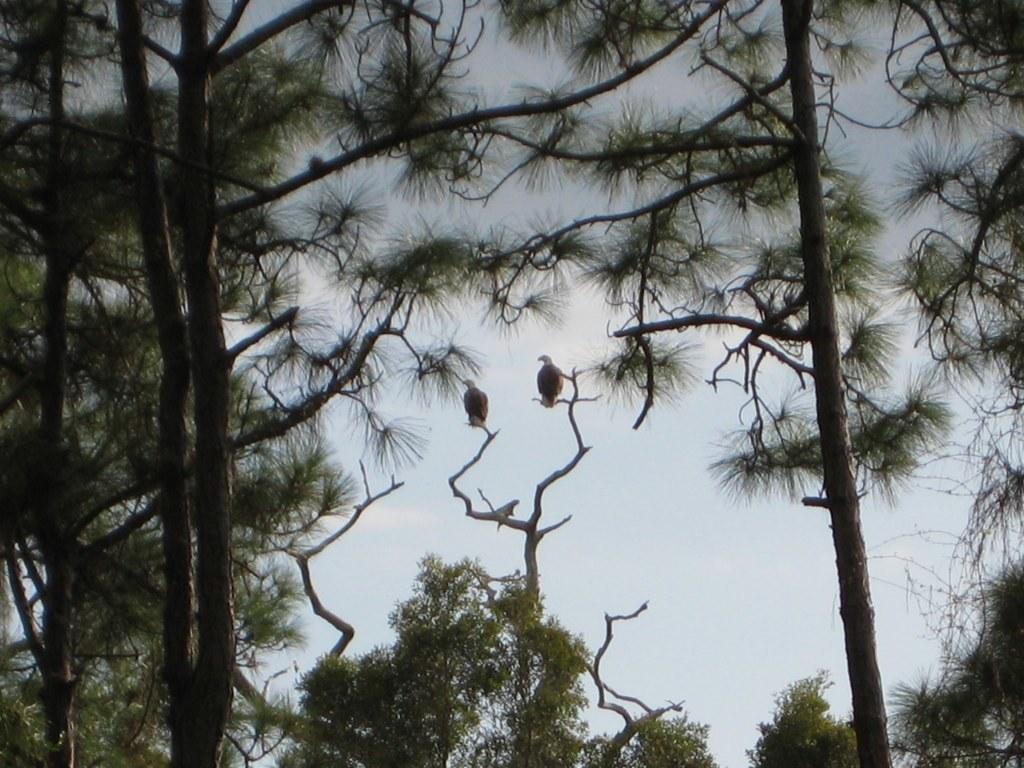What can be seen in the foreground of the image? There are trees and two birds on a stem in the foreground of the image. What is visible in the background of the image? The sky is visible in the background of the image. What type of reward is being given to the birds in the image? There is no reward being given to the birds in the image; the birds are simply perched on a stem. How many vases are present in the image? There is no vase present in the image. 